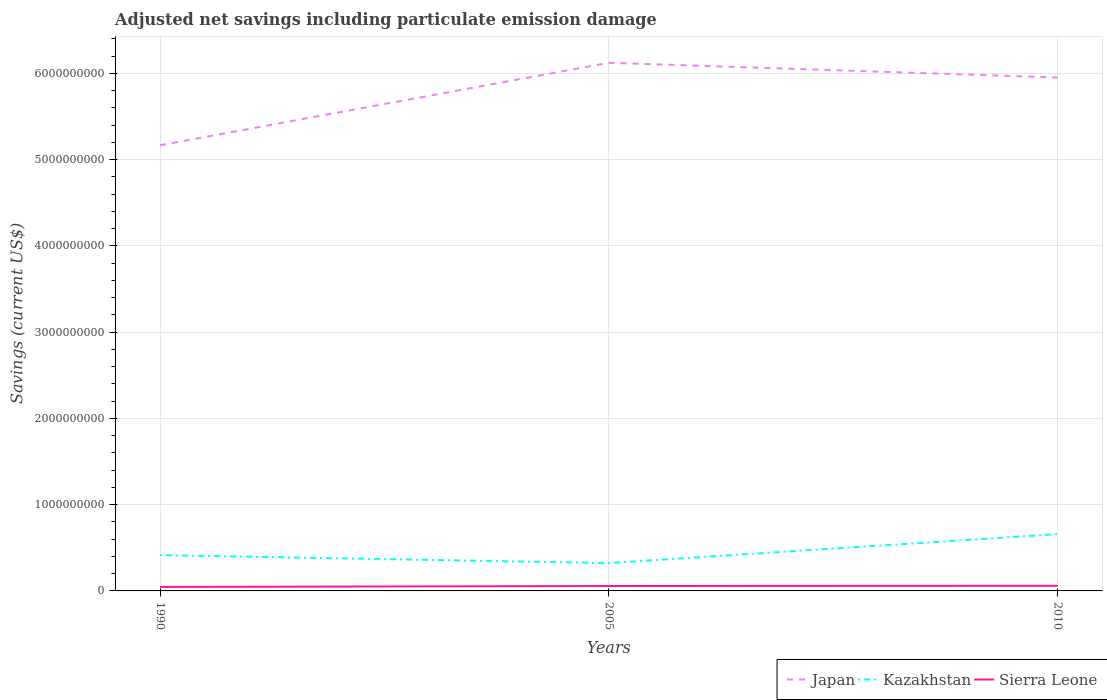How many different coloured lines are there?
Provide a succinct answer. 3. Across all years, what is the maximum net savings in Kazakhstan?
Provide a short and direct response. 3.23e+08. What is the total net savings in Japan in the graph?
Keep it short and to the point. -7.85e+08. What is the difference between the highest and the second highest net savings in Japan?
Your response must be concise. 9.56e+08. Is the net savings in Sierra Leone strictly greater than the net savings in Kazakhstan over the years?
Provide a short and direct response. Yes. Are the values on the major ticks of Y-axis written in scientific E-notation?
Your answer should be very brief. No. Where does the legend appear in the graph?
Offer a terse response. Bottom right. How are the legend labels stacked?
Provide a succinct answer. Horizontal. What is the title of the graph?
Your response must be concise. Adjusted net savings including particulate emission damage. What is the label or title of the X-axis?
Your response must be concise. Years. What is the label or title of the Y-axis?
Ensure brevity in your answer.  Savings (current US$). What is the Savings (current US$) of Japan in 1990?
Your answer should be compact. 5.17e+09. What is the Savings (current US$) of Kazakhstan in 1990?
Make the answer very short. 4.15e+08. What is the Savings (current US$) of Sierra Leone in 1990?
Offer a terse response. 4.66e+07. What is the Savings (current US$) in Japan in 2005?
Your response must be concise. 6.12e+09. What is the Savings (current US$) of Kazakhstan in 2005?
Your answer should be compact. 3.23e+08. What is the Savings (current US$) of Sierra Leone in 2005?
Keep it short and to the point. 5.69e+07. What is the Savings (current US$) in Japan in 2010?
Your answer should be compact. 5.95e+09. What is the Savings (current US$) of Kazakhstan in 2010?
Your answer should be very brief. 6.59e+08. What is the Savings (current US$) in Sierra Leone in 2010?
Offer a terse response. 5.95e+07. Across all years, what is the maximum Savings (current US$) of Japan?
Offer a terse response. 6.12e+09. Across all years, what is the maximum Savings (current US$) in Kazakhstan?
Your answer should be compact. 6.59e+08. Across all years, what is the maximum Savings (current US$) in Sierra Leone?
Your answer should be very brief. 5.95e+07. Across all years, what is the minimum Savings (current US$) of Japan?
Ensure brevity in your answer.  5.17e+09. Across all years, what is the minimum Savings (current US$) in Kazakhstan?
Your response must be concise. 3.23e+08. Across all years, what is the minimum Savings (current US$) of Sierra Leone?
Make the answer very short. 4.66e+07. What is the total Savings (current US$) in Japan in the graph?
Your response must be concise. 1.72e+1. What is the total Savings (current US$) of Kazakhstan in the graph?
Give a very brief answer. 1.40e+09. What is the total Savings (current US$) of Sierra Leone in the graph?
Ensure brevity in your answer.  1.63e+08. What is the difference between the Savings (current US$) in Japan in 1990 and that in 2005?
Your answer should be compact. -9.56e+08. What is the difference between the Savings (current US$) in Kazakhstan in 1990 and that in 2005?
Your answer should be very brief. 9.18e+07. What is the difference between the Savings (current US$) in Sierra Leone in 1990 and that in 2005?
Your response must be concise. -1.02e+07. What is the difference between the Savings (current US$) of Japan in 1990 and that in 2010?
Your answer should be very brief. -7.85e+08. What is the difference between the Savings (current US$) of Kazakhstan in 1990 and that in 2010?
Your answer should be very brief. -2.44e+08. What is the difference between the Savings (current US$) in Sierra Leone in 1990 and that in 2010?
Make the answer very short. -1.29e+07. What is the difference between the Savings (current US$) of Japan in 2005 and that in 2010?
Offer a very short reply. 1.71e+08. What is the difference between the Savings (current US$) in Kazakhstan in 2005 and that in 2010?
Offer a very short reply. -3.36e+08. What is the difference between the Savings (current US$) in Sierra Leone in 2005 and that in 2010?
Offer a very short reply. -2.64e+06. What is the difference between the Savings (current US$) of Japan in 1990 and the Savings (current US$) of Kazakhstan in 2005?
Give a very brief answer. 4.84e+09. What is the difference between the Savings (current US$) in Japan in 1990 and the Savings (current US$) in Sierra Leone in 2005?
Your answer should be compact. 5.11e+09. What is the difference between the Savings (current US$) of Kazakhstan in 1990 and the Savings (current US$) of Sierra Leone in 2005?
Your response must be concise. 3.58e+08. What is the difference between the Savings (current US$) of Japan in 1990 and the Savings (current US$) of Kazakhstan in 2010?
Keep it short and to the point. 4.51e+09. What is the difference between the Savings (current US$) of Japan in 1990 and the Savings (current US$) of Sierra Leone in 2010?
Keep it short and to the point. 5.11e+09. What is the difference between the Savings (current US$) of Kazakhstan in 1990 and the Savings (current US$) of Sierra Leone in 2010?
Provide a succinct answer. 3.55e+08. What is the difference between the Savings (current US$) of Japan in 2005 and the Savings (current US$) of Kazakhstan in 2010?
Your response must be concise. 5.46e+09. What is the difference between the Savings (current US$) of Japan in 2005 and the Savings (current US$) of Sierra Leone in 2010?
Give a very brief answer. 6.06e+09. What is the difference between the Savings (current US$) in Kazakhstan in 2005 and the Savings (current US$) in Sierra Leone in 2010?
Give a very brief answer. 2.64e+08. What is the average Savings (current US$) of Japan per year?
Provide a succinct answer. 5.75e+09. What is the average Savings (current US$) of Kazakhstan per year?
Provide a succinct answer. 4.66e+08. What is the average Savings (current US$) in Sierra Leone per year?
Give a very brief answer. 5.43e+07. In the year 1990, what is the difference between the Savings (current US$) in Japan and Savings (current US$) in Kazakhstan?
Your answer should be compact. 4.75e+09. In the year 1990, what is the difference between the Savings (current US$) in Japan and Savings (current US$) in Sierra Leone?
Offer a terse response. 5.12e+09. In the year 1990, what is the difference between the Savings (current US$) of Kazakhstan and Savings (current US$) of Sierra Leone?
Your response must be concise. 3.68e+08. In the year 2005, what is the difference between the Savings (current US$) of Japan and Savings (current US$) of Kazakhstan?
Provide a succinct answer. 5.80e+09. In the year 2005, what is the difference between the Savings (current US$) of Japan and Savings (current US$) of Sierra Leone?
Your answer should be compact. 6.07e+09. In the year 2005, what is the difference between the Savings (current US$) in Kazakhstan and Savings (current US$) in Sierra Leone?
Your response must be concise. 2.66e+08. In the year 2010, what is the difference between the Savings (current US$) of Japan and Savings (current US$) of Kazakhstan?
Provide a short and direct response. 5.29e+09. In the year 2010, what is the difference between the Savings (current US$) of Japan and Savings (current US$) of Sierra Leone?
Offer a very short reply. 5.89e+09. In the year 2010, what is the difference between the Savings (current US$) of Kazakhstan and Savings (current US$) of Sierra Leone?
Make the answer very short. 5.99e+08. What is the ratio of the Savings (current US$) in Japan in 1990 to that in 2005?
Offer a terse response. 0.84. What is the ratio of the Savings (current US$) of Kazakhstan in 1990 to that in 2005?
Offer a terse response. 1.28. What is the ratio of the Savings (current US$) of Sierra Leone in 1990 to that in 2005?
Ensure brevity in your answer.  0.82. What is the ratio of the Savings (current US$) in Japan in 1990 to that in 2010?
Provide a short and direct response. 0.87. What is the ratio of the Savings (current US$) in Kazakhstan in 1990 to that in 2010?
Your answer should be compact. 0.63. What is the ratio of the Savings (current US$) in Sierra Leone in 1990 to that in 2010?
Your answer should be compact. 0.78. What is the ratio of the Savings (current US$) in Japan in 2005 to that in 2010?
Offer a terse response. 1.03. What is the ratio of the Savings (current US$) in Kazakhstan in 2005 to that in 2010?
Your answer should be compact. 0.49. What is the ratio of the Savings (current US$) of Sierra Leone in 2005 to that in 2010?
Give a very brief answer. 0.96. What is the difference between the highest and the second highest Savings (current US$) of Japan?
Offer a very short reply. 1.71e+08. What is the difference between the highest and the second highest Savings (current US$) in Kazakhstan?
Offer a very short reply. 2.44e+08. What is the difference between the highest and the second highest Savings (current US$) of Sierra Leone?
Offer a very short reply. 2.64e+06. What is the difference between the highest and the lowest Savings (current US$) of Japan?
Your answer should be compact. 9.56e+08. What is the difference between the highest and the lowest Savings (current US$) of Kazakhstan?
Your response must be concise. 3.36e+08. What is the difference between the highest and the lowest Savings (current US$) of Sierra Leone?
Provide a succinct answer. 1.29e+07. 